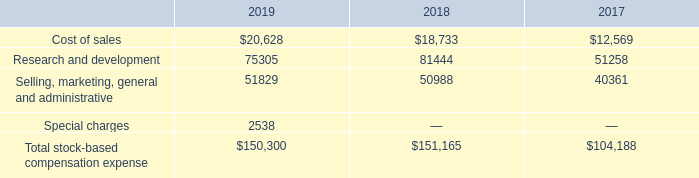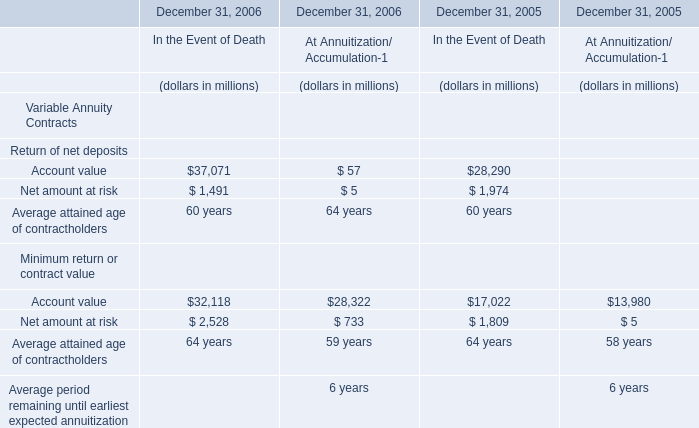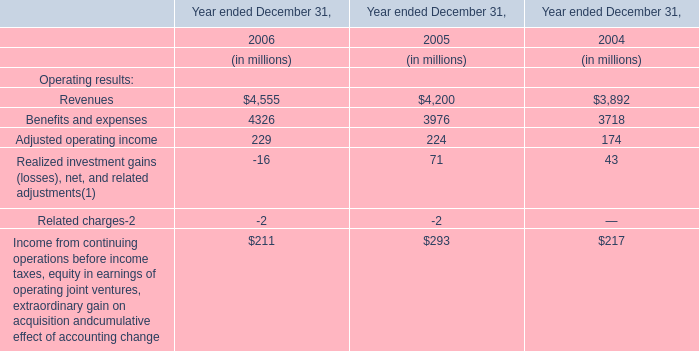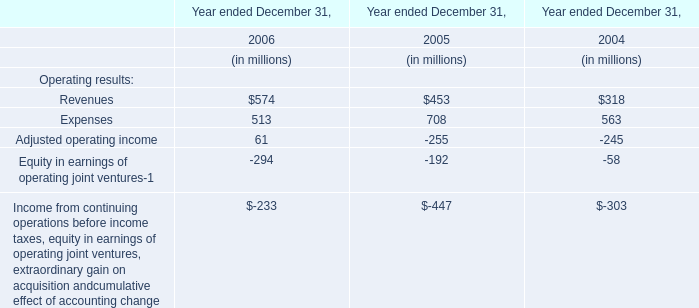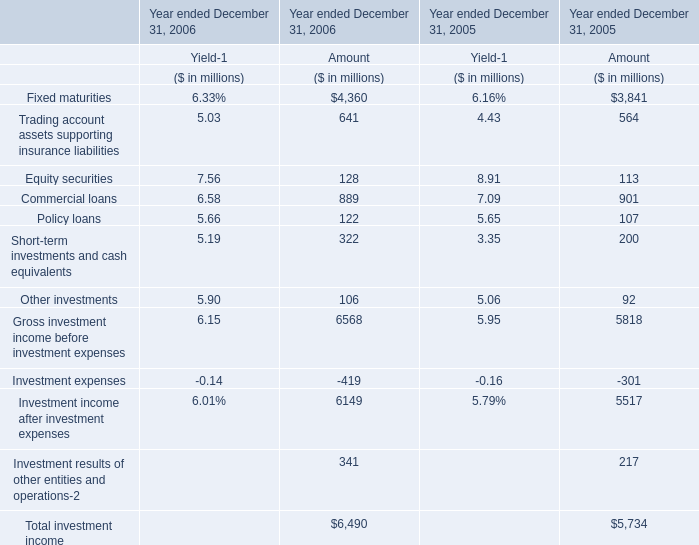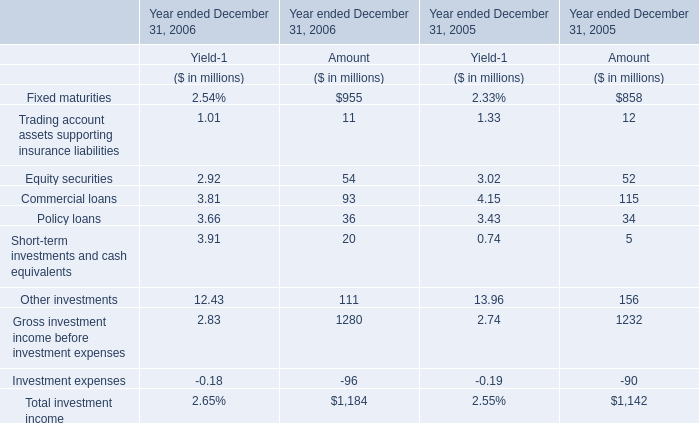What was the total amount of Amount in the range of 100 and 1000 in 2006 for Amount? (in million) 
Computations: (955 + 111)
Answer: 1066.0. 